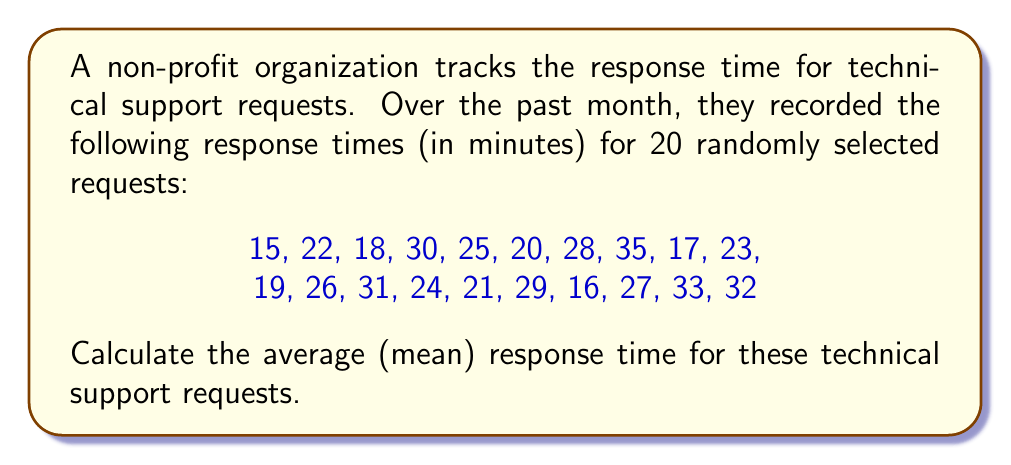Can you solve this math problem? To calculate the average (mean) response time, we need to follow these steps:

1. Sum up all the response times:
   $$ \text{Total} = 15 + 22 + 18 + 30 + 25 + 20 + 28 + 35 + 17 + 23 + 19 + 26 + 31 + 24 + 21 + 29 + 16 + 27 + 33 + 32 $$
   $$ \text{Total} = 491 \text{ minutes} $$

2. Count the total number of requests:
   $$ n = 20 $$

3. Calculate the mean by dividing the total by the number of requests:
   $$ \text{Mean} = \frac{\text{Total}}{n} = \frac{491}{20} = 24.55 \text{ minutes} $$

Therefore, the average response time for technical support requests is 24.55 minutes.
Answer: 24.55 minutes 